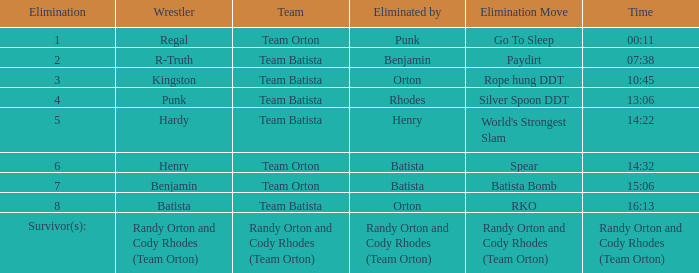What time was the Wrestler Henry eliminated by Batista? 14:32. 